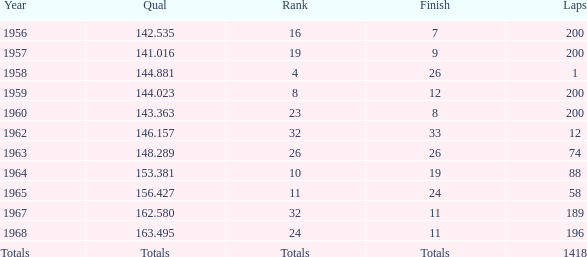Would you mind parsing the complete table? {'header': ['Year', 'Qual', 'Rank', 'Finish', 'Laps'], 'rows': [['1956', '142.535', '16', '7', '200'], ['1957', '141.016', '19', '9', '200'], ['1958', '144.881', '4', '26', '1'], ['1959', '144.023', '8', '12', '200'], ['1960', '143.363', '23', '8', '200'], ['1962', '146.157', '32', '33', '12'], ['1963', '148.289', '26', '26', '74'], ['1964', '153.381', '10', '19', '88'], ['1965', '156.427', '11', '24', '58'], ['1967', '162.580', '32', '11', '189'], ['1968', '163.495', '24', '11', '196'], ['Totals', 'Totals', 'Totals', 'Totals', '1418']]} What is the greatest number of laps that results in a cumulative total of 8? 200.0. 